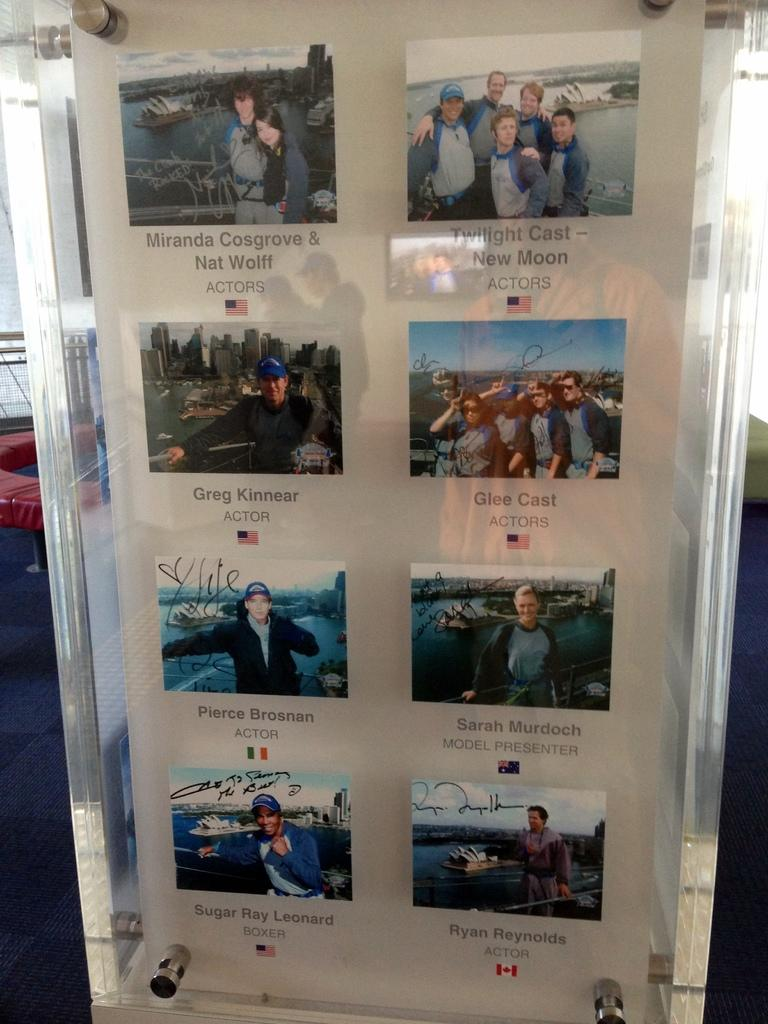<image>
Provide a brief description of the given image. Photos of actors include the Glee Cast and Greg Kinnear 